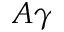<formula> <loc_0><loc_0><loc_500><loc_500>A \gamma</formula> 